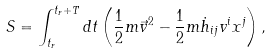Convert formula to latex. <formula><loc_0><loc_0><loc_500><loc_500>S = \int _ { t _ { r } } ^ { t _ { r } + T } d t \left ( \frac { 1 } { 2 } m \vec { v } ^ { 2 } - \frac { 1 } { 2 } m \dot { h } _ { i j } v ^ { i } x ^ { j } \right ) ,</formula> 